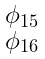Convert formula to latex. <formula><loc_0><loc_0><loc_500><loc_500>\begin{smallmatrix} \phi _ { 1 5 } \\ \phi _ { 1 6 } \end{smallmatrix}</formula> 